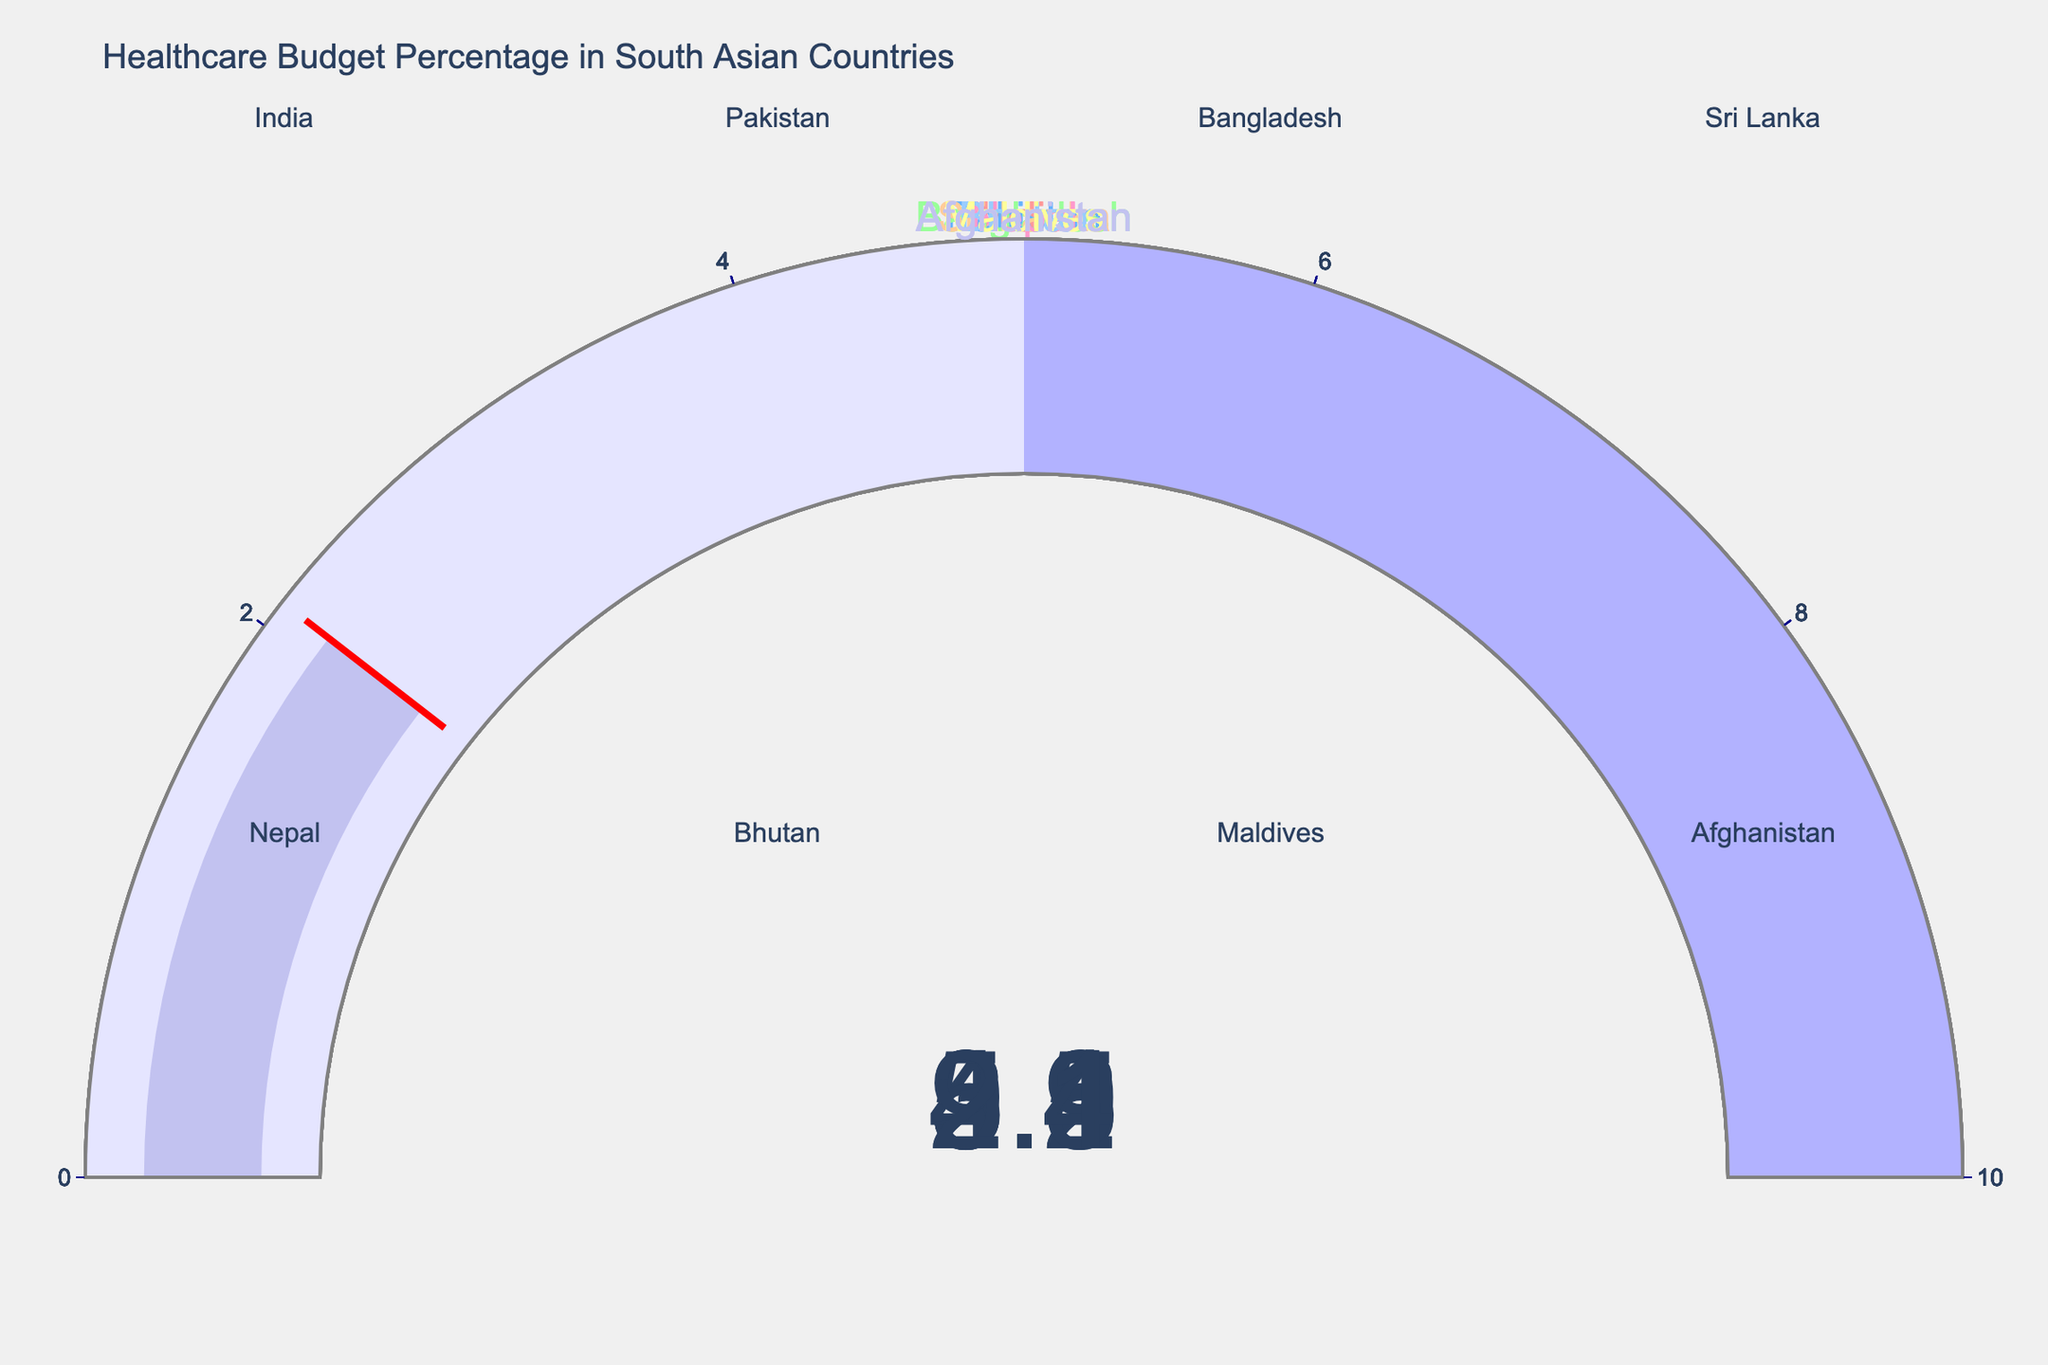What is the title of the figure? The title can be seen at the top of the figure. It reads "Healthcare Budget Percentage in South Asian Countries".
Answer: Healthcare Budget Percentage in South Asian Countries Which country has the highest healthcare budget percentage? By examining the gauge charts, the Maldives has the highest healthcare budget percentage at 9.4%.
Answer: Maldives What is the healthcare budget percentage for Bangladesh? Look at the gauge corresponding to Bangladesh, which shows 2.8%.
Answer: 2.8% Which countries have a healthcare budget percentage lower than 3%? By identifying and comparing the values on each gauge, Afghanistan and Bangladesh have values lower than 3%, specifically 2.1% and 2.8% respectively.
Answer: Afghanistan, Bangladesh How many countries have a healthcare budget percentage above 5%? From the eight gauge charts, only Nepal and Maldives have values above 5%, being 5.2% and 9.4% respectively.
Answer: 2 What is the difference in healthcare budget percentage between Nepal and India? The gauge chart shows 5.2% for Nepal and 3.5% for India. Subtracting these values gives 1.7%.
Answer: 1.7% Which country has a healthcare budget closest to 4%? By viewing the gauge charts, Sri Lanka, with a value of 4.1%, is the closest to 4%.
Answer: Sri Lanka What is the average healthcare budget percentage among all the countries? Sum the percentages (3.5 + 3.2 + 2.8 + 4.1 + 5.2 + 3.9 + 9.4 + 2.1 = 34.2) and divide by the number of countries (8). The average is 34.2 / 8 = 4.275%.
Answer: 4.275% What is the median healthcare budget percentage? First, sort the values: 2.1, 2.8, 3.2, 3.5, 3.9, 4.1, 5.2, 9.4. The middle two values are 3.5 and 3.9, so the median is (3.5 + 3.9) / 2 = 3.7%.
Answer: 3.7% By how much does the healthcare budget percentage of the country with the highest value exceed that of the country with the lowest value? The Maldives has the highest at 9.4%, and Afghanistan the lowest at 2.1%. The difference is 9.4 - 2.1 = 7.3%.
Answer: 7.3% 